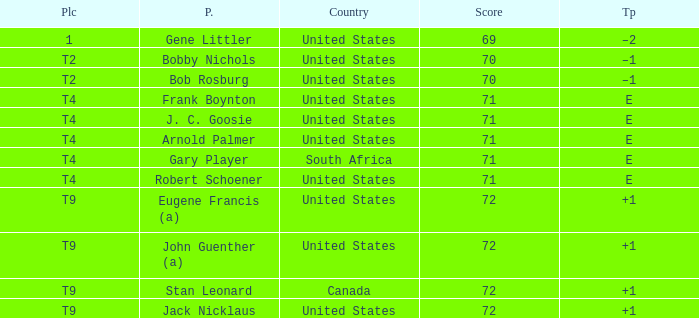What is To Par, when Country is "United States", when Place is "T4", and when Player is "Frank Boynton"? E. 